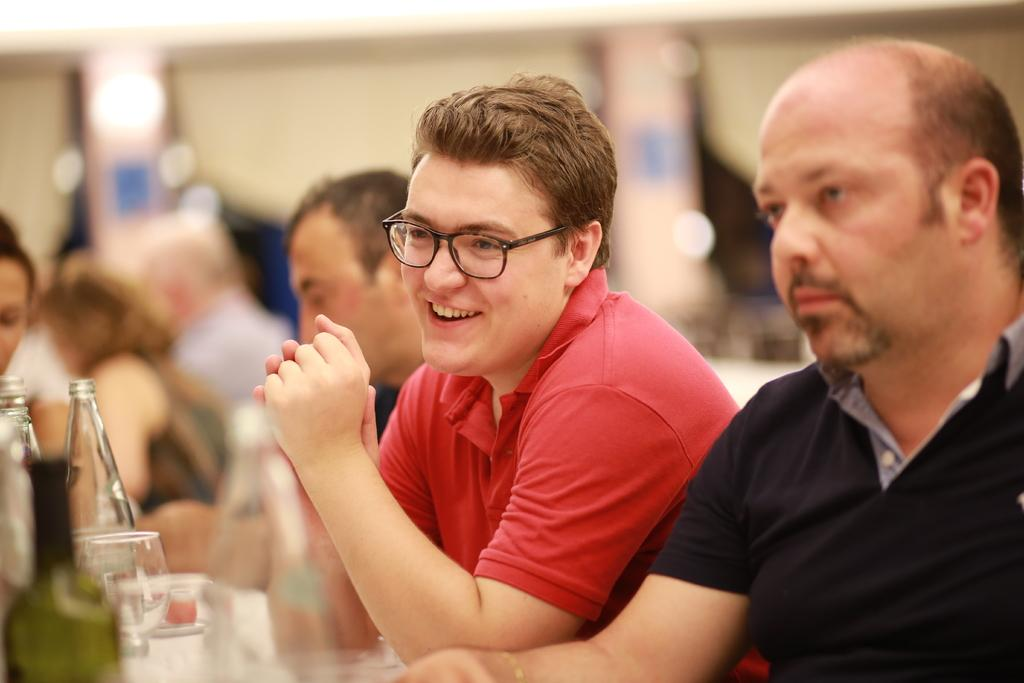What are the people in the image doing? There are people sitting in the image. What objects can be seen on the table in the image? There are glass bottles and glasses in the image. What can be seen illuminating the scene in the image? There are lights visible in the image. How many people are present in the image? There are other people present in the image. What type of flowers are on the table in the image? There are no flowers present in the image. Is there a bomb visible in the image? There is no bomb present in the image. 